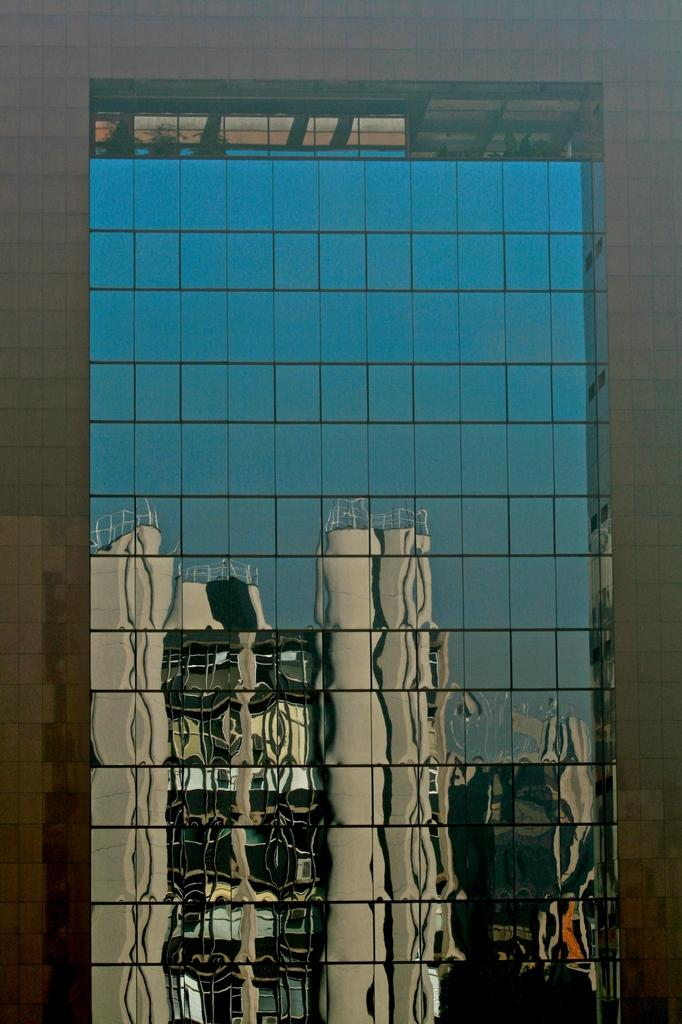What type of building is visible in the image? There is a building with glass in the image. What feature of the building is particularly noteworthy? The glass on the building reflects another building. How many sticks are leaning against the building in the image? There are no sticks present in the image. Are there any crates visible near the building in the image? There is no mention of crates in the provided facts, so we cannot determine if any are present in the image. Can you see any lizards crawling on the glass of the building in the image? There is no mention of lizards in the provided facts, so we cannot determine if any are present in the image. 